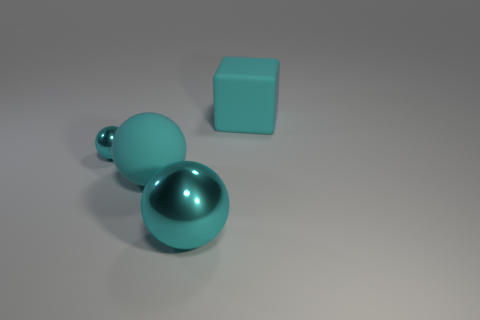Subtract all cyan balls. How many were subtracted if there are1cyan balls left? 2 Subtract all rubber spheres. How many spheres are left? 2 Add 1 small cyan balls. How many objects exist? 5 Subtract all cubes. How many objects are left? 3 Subtract all brown balls. Subtract all blue blocks. How many balls are left? 3 Add 4 yellow matte balls. How many yellow matte balls exist? 4 Subtract 0 blue spheres. How many objects are left? 4 Subtract all tiny cyan blocks. Subtract all cyan objects. How many objects are left? 0 Add 3 matte cubes. How many matte cubes are left? 4 